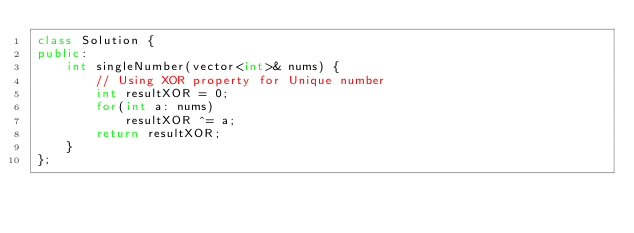Convert code to text. <code><loc_0><loc_0><loc_500><loc_500><_C++_>class Solution {
public:
    int singleNumber(vector<int>& nums) {        
        // Using XOR property for Unique number
        int resultXOR = 0;                
        for(int a: nums)
            resultXOR ^= a;        
        return resultXOR;            
    }
};</code> 